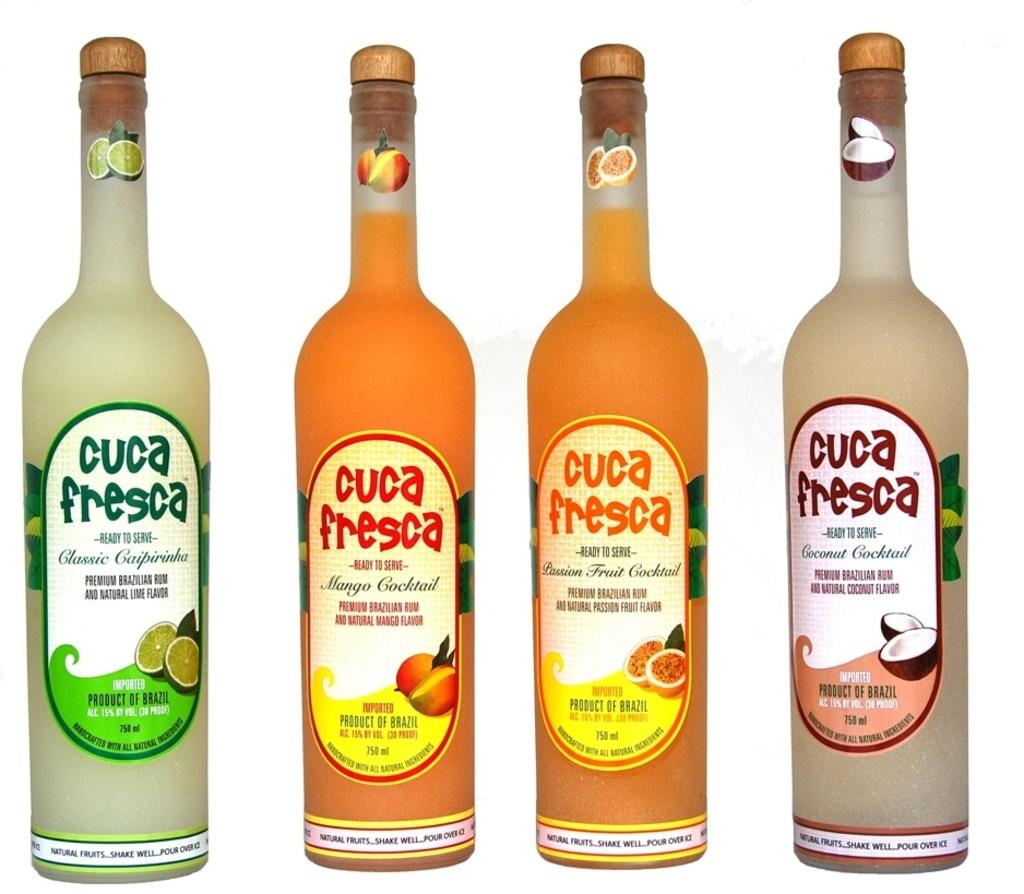Provide a one-sentence caption for the provided image. Four bottles of Cuca Fresca all different colors. 